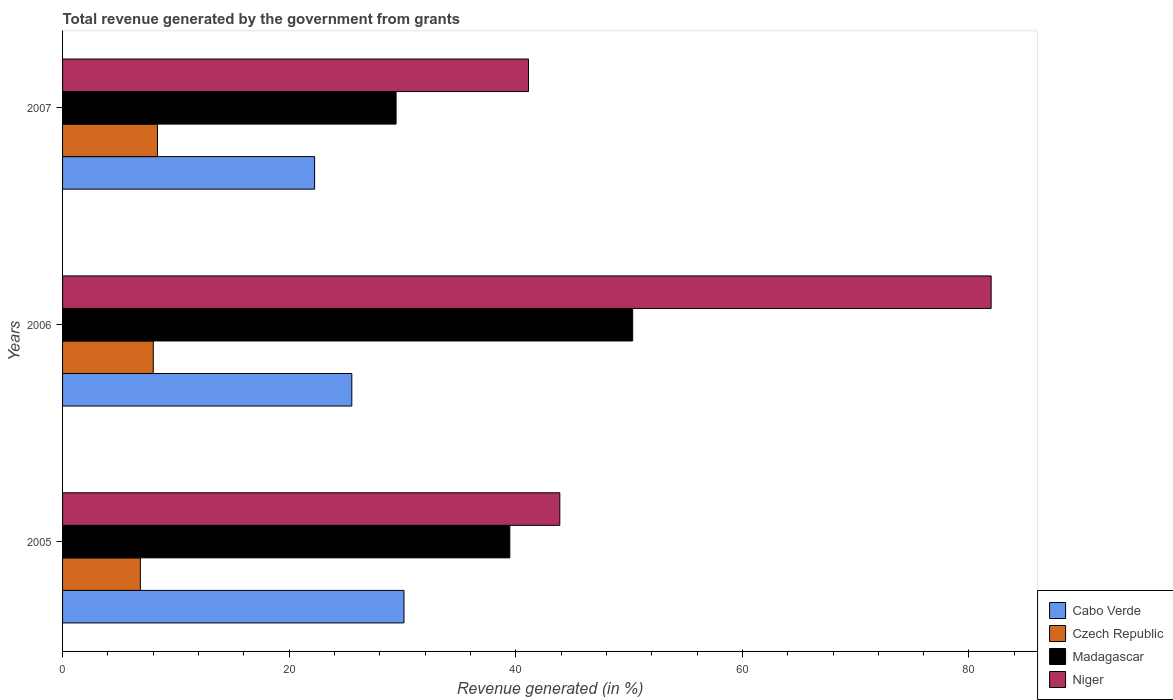How many different coloured bars are there?
Provide a succinct answer. 4. Are the number of bars on each tick of the Y-axis equal?
Keep it short and to the point. Yes. How many bars are there on the 3rd tick from the top?
Ensure brevity in your answer.  4. What is the total revenue generated in Madagascar in 2005?
Provide a succinct answer. 39.48. Across all years, what is the maximum total revenue generated in Cabo Verde?
Provide a succinct answer. 30.13. Across all years, what is the minimum total revenue generated in Niger?
Ensure brevity in your answer.  41.12. What is the total total revenue generated in Cabo Verde in the graph?
Offer a very short reply. 77.91. What is the difference between the total revenue generated in Madagascar in 2005 and that in 2006?
Your answer should be compact. -10.84. What is the difference between the total revenue generated in Niger in 2006 and the total revenue generated in Czech Republic in 2007?
Keep it short and to the point. 73.58. What is the average total revenue generated in Niger per year?
Your answer should be compact. 55.65. In the year 2005, what is the difference between the total revenue generated in Czech Republic and total revenue generated in Cabo Verde?
Offer a terse response. -23.27. In how many years, is the total revenue generated in Niger greater than 16 %?
Provide a short and direct response. 3. What is the ratio of the total revenue generated in Cabo Verde in 2005 to that in 2006?
Your answer should be compact. 1.18. Is the total revenue generated in Niger in 2005 less than that in 2007?
Your answer should be very brief. No. Is the difference between the total revenue generated in Czech Republic in 2006 and 2007 greater than the difference between the total revenue generated in Cabo Verde in 2006 and 2007?
Provide a succinct answer. No. What is the difference between the highest and the second highest total revenue generated in Czech Republic?
Offer a terse response. 0.37. What is the difference between the highest and the lowest total revenue generated in Madagascar?
Give a very brief answer. 20.88. In how many years, is the total revenue generated in Czech Republic greater than the average total revenue generated in Czech Republic taken over all years?
Ensure brevity in your answer.  2. Is the sum of the total revenue generated in Madagascar in 2006 and 2007 greater than the maximum total revenue generated in Cabo Verde across all years?
Provide a succinct answer. Yes. Is it the case that in every year, the sum of the total revenue generated in Cabo Verde and total revenue generated in Czech Republic is greater than the sum of total revenue generated in Madagascar and total revenue generated in Niger?
Make the answer very short. No. What does the 4th bar from the top in 2005 represents?
Provide a short and direct response. Cabo Verde. What does the 3rd bar from the bottom in 2005 represents?
Provide a short and direct response. Madagascar. Is it the case that in every year, the sum of the total revenue generated in Cabo Verde and total revenue generated in Madagascar is greater than the total revenue generated in Niger?
Keep it short and to the point. No. How many bars are there?
Offer a terse response. 12. Are all the bars in the graph horizontal?
Your answer should be very brief. Yes. How many years are there in the graph?
Provide a short and direct response. 3. What is the difference between two consecutive major ticks on the X-axis?
Offer a terse response. 20. Are the values on the major ticks of X-axis written in scientific E-notation?
Your response must be concise. No. Does the graph contain any zero values?
Keep it short and to the point. No. How many legend labels are there?
Offer a very short reply. 4. What is the title of the graph?
Make the answer very short. Total revenue generated by the government from grants. Does "Eritrea" appear as one of the legend labels in the graph?
Provide a short and direct response. No. What is the label or title of the X-axis?
Offer a terse response. Revenue generated (in %). What is the Revenue generated (in %) in Cabo Verde in 2005?
Provide a short and direct response. 30.13. What is the Revenue generated (in %) in Czech Republic in 2005?
Provide a short and direct response. 6.87. What is the Revenue generated (in %) of Madagascar in 2005?
Provide a succinct answer. 39.48. What is the Revenue generated (in %) in Niger in 2005?
Offer a terse response. 43.89. What is the Revenue generated (in %) of Cabo Verde in 2006?
Give a very brief answer. 25.53. What is the Revenue generated (in %) of Czech Republic in 2006?
Your answer should be compact. 8.01. What is the Revenue generated (in %) in Madagascar in 2006?
Offer a very short reply. 50.32. What is the Revenue generated (in %) in Niger in 2006?
Offer a terse response. 81.96. What is the Revenue generated (in %) in Cabo Verde in 2007?
Your answer should be very brief. 22.25. What is the Revenue generated (in %) in Czech Republic in 2007?
Make the answer very short. 8.37. What is the Revenue generated (in %) of Madagascar in 2007?
Make the answer very short. 29.44. What is the Revenue generated (in %) of Niger in 2007?
Offer a very short reply. 41.12. Across all years, what is the maximum Revenue generated (in %) of Cabo Verde?
Keep it short and to the point. 30.13. Across all years, what is the maximum Revenue generated (in %) of Czech Republic?
Provide a short and direct response. 8.37. Across all years, what is the maximum Revenue generated (in %) of Madagascar?
Your answer should be very brief. 50.32. Across all years, what is the maximum Revenue generated (in %) of Niger?
Make the answer very short. 81.96. Across all years, what is the minimum Revenue generated (in %) of Cabo Verde?
Provide a short and direct response. 22.25. Across all years, what is the minimum Revenue generated (in %) of Czech Republic?
Give a very brief answer. 6.87. Across all years, what is the minimum Revenue generated (in %) of Madagascar?
Provide a short and direct response. 29.44. Across all years, what is the minimum Revenue generated (in %) of Niger?
Offer a very short reply. 41.12. What is the total Revenue generated (in %) of Cabo Verde in the graph?
Provide a succinct answer. 77.91. What is the total Revenue generated (in %) of Czech Republic in the graph?
Offer a very short reply. 23.25. What is the total Revenue generated (in %) in Madagascar in the graph?
Your answer should be compact. 119.23. What is the total Revenue generated (in %) of Niger in the graph?
Give a very brief answer. 166.96. What is the difference between the Revenue generated (in %) of Cabo Verde in 2005 and that in 2006?
Make the answer very short. 4.61. What is the difference between the Revenue generated (in %) in Czech Republic in 2005 and that in 2006?
Give a very brief answer. -1.14. What is the difference between the Revenue generated (in %) in Madagascar in 2005 and that in 2006?
Make the answer very short. -10.84. What is the difference between the Revenue generated (in %) in Niger in 2005 and that in 2006?
Make the answer very short. -38.07. What is the difference between the Revenue generated (in %) in Cabo Verde in 2005 and that in 2007?
Your response must be concise. 7.89. What is the difference between the Revenue generated (in %) of Czech Republic in 2005 and that in 2007?
Provide a succinct answer. -1.51. What is the difference between the Revenue generated (in %) of Madagascar in 2005 and that in 2007?
Offer a very short reply. 10.04. What is the difference between the Revenue generated (in %) in Niger in 2005 and that in 2007?
Ensure brevity in your answer.  2.76. What is the difference between the Revenue generated (in %) in Cabo Verde in 2006 and that in 2007?
Your response must be concise. 3.28. What is the difference between the Revenue generated (in %) in Czech Republic in 2006 and that in 2007?
Your response must be concise. -0.37. What is the difference between the Revenue generated (in %) in Madagascar in 2006 and that in 2007?
Provide a succinct answer. 20.88. What is the difference between the Revenue generated (in %) of Niger in 2006 and that in 2007?
Offer a very short reply. 40.83. What is the difference between the Revenue generated (in %) of Cabo Verde in 2005 and the Revenue generated (in %) of Czech Republic in 2006?
Provide a succinct answer. 22.13. What is the difference between the Revenue generated (in %) of Cabo Verde in 2005 and the Revenue generated (in %) of Madagascar in 2006?
Ensure brevity in your answer.  -20.18. What is the difference between the Revenue generated (in %) of Cabo Verde in 2005 and the Revenue generated (in %) of Niger in 2006?
Give a very brief answer. -51.82. What is the difference between the Revenue generated (in %) in Czech Republic in 2005 and the Revenue generated (in %) in Madagascar in 2006?
Keep it short and to the point. -43.45. What is the difference between the Revenue generated (in %) in Czech Republic in 2005 and the Revenue generated (in %) in Niger in 2006?
Give a very brief answer. -75.09. What is the difference between the Revenue generated (in %) in Madagascar in 2005 and the Revenue generated (in %) in Niger in 2006?
Make the answer very short. -42.48. What is the difference between the Revenue generated (in %) in Cabo Verde in 2005 and the Revenue generated (in %) in Czech Republic in 2007?
Your response must be concise. 21.76. What is the difference between the Revenue generated (in %) of Cabo Verde in 2005 and the Revenue generated (in %) of Madagascar in 2007?
Offer a very short reply. 0.7. What is the difference between the Revenue generated (in %) in Cabo Verde in 2005 and the Revenue generated (in %) in Niger in 2007?
Your answer should be compact. -10.99. What is the difference between the Revenue generated (in %) of Czech Republic in 2005 and the Revenue generated (in %) of Madagascar in 2007?
Your response must be concise. -22.57. What is the difference between the Revenue generated (in %) in Czech Republic in 2005 and the Revenue generated (in %) in Niger in 2007?
Your answer should be compact. -34.26. What is the difference between the Revenue generated (in %) in Madagascar in 2005 and the Revenue generated (in %) in Niger in 2007?
Your answer should be compact. -1.65. What is the difference between the Revenue generated (in %) in Cabo Verde in 2006 and the Revenue generated (in %) in Czech Republic in 2007?
Offer a terse response. 17.15. What is the difference between the Revenue generated (in %) of Cabo Verde in 2006 and the Revenue generated (in %) of Madagascar in 2007?
Give a very brief answer. -3.91. What is the difference between the Revenue generated (in %) in Cabo Verde in 2006 and the Revenue generated (in %) in Niger in 2007?
Your answer should be very brief. -15.6. What is the difference between the Revenue generated (in %) of Czech Republic in 2006 and the Revenue generated (in %) of Madagascar in 2007?
Your response must be concise. -21.43. What is the difference between the Revenue generated (in %) in Czech Republic in 2006 and the Revenue generated (in %) in Niger in 2007?
Offer a very short reply. -33.12. What is the difference between the Revenue generated (in %) of Madagascar in 2006 and the Revenue generated (in %) of Niger in 2007?
Your answer should be compact. 9.19. What is the average Revenue generated (in %) of Cabo Verde per year?
Offer a terse response. 25.97. What is the average Revenue generated (in %) in Czech Republic per year?
Offer a very short reply. 7.75. What is the average Revenue generated (in %) of Madagascar per year?
Offer a terse response. 39.74. What is the average Revenue generated (in %) in Niger per year?
Your answer should be very brief. 55.65. In the year 2005, what is the difference between the Revenue generated (in %) of Cabo Verde and Revenue generated (in %) of Czech Republic?
Ensure brevity in your answer.  23.27. In the year 2005, what is the difference between the Revenue generated (in %) of Cabo Verde and Revenue generated (in %) of Madagascar?
Provide a succinct answer. -9.34. In the year 2005, what is the difference between the Revenue generated (in %) in Cabo Verde and Revenue generated (in %) in Niger?
Your answer should be compact. -13.75. In the year 2005, what is the difference between the Revenue generated (in %) of Czech Republic and Revenue generated (in %) of Madagascar?
Your response must be concise. -32.61. In the year 2005, what is the difference between the Revenue generated (in %) in Czech Republic and Revenue generated (in %) in Niger?
Your answer should be very brief. -37.02. In the year 2005, what is the difference between the Revenue generated (in %) of Madagascar and Revenue generated (in %) of Niger?
Your answer should be very brief. -4.41. In the year 2006, what is the difference between the Revenue generated (in %) in Cabo Verde and Revenue generated (in %) in Czech Republic?
Offer a terse response. 17.52. In the year 2006, what is the difference between the Revenue generated (in %) of Cabo Verde and Revenue generated (in %) of Madagascar?
Offer a terse response. -24.79. In the year 2006, what is the difference between the Revenue generated (in %) in Cabo Verde and Revenue generated (in %) in Niger?
Your response must be concise. -56.43. In the year 2006, what is the difference between the Revenue generated (in %) in Czech Republic and Revenue generated (in %) in Madagascar?
Keep it short and to the point. -42.31. In the year 2006, what is the difference between the Revenue generated (in %) of Czech Republic and Revenue generated (in %) of Niger?
Your answer should be compact. -73.95. In the year 2006, what is the difference between the Revenue generated (in %) in Madagascar and Revenue generated (in %) in Niger?
Your answer should be compact. -31.64. In the year 2007, what is the difference between the Revenue generated (in %) of Cabo Verde and Revenue generated (in %) of Czech Republic?
Ensure brevity in your answer.  13.87. In the year 2007, what is the difference between the Revenue generated (in %) in Cabo Verde and Revenue generated (in %) in Madagascar?
Keep it short and to the point. -7.19. In the year 2007, what is the difference between the Revenue generated (in %) of Cabo Verde and Revenue generated (in %) of Niger?
Ensure brevity in your answer.  -18.88. In the year 2007, what is the difference between the Revenue generated (in %) in Czech Republic and Revenue generated (in %) in Madagascar?
Provide a succinct answer. -21.06. In the year 2007, what is the difference between the Revenue generated (in %) of Czech Republic and Revenue generated (in %) of Niger?
Provide a short and direct response. -32.75. In the year 2007, what is the difference between the Revenue generated (in %) of Madagascar and Revenue generated (in %) of Niger?
Your answer should be very brief. -11.69. What is the ratio of the Revenue generated (in %) of Cabo Verde in 2005 to that in 2006?
Provide a succinct answer. 1.18. What is the ratio of the Revenue generated (in %) in Czech Republic in 2005 to that in 2006?
Make the answer very short. 0.86. What is the ratio of the Revenue generated (in %) of Madagascar in 2005 to that in 2006?
Offer a very short reply. 0.78. What is the ratio of the Revenue generated (in %) of Niger in 2005 to that in 2006?
Provide a succinct answer. 0.54. What is the ratio of the Revenue generated (in %) of Cabo Verde in 2005 to that in 2007?
Make the answer very short. 1.35. What is the ratio of the Revenue generated (in %) in Czech Republic in 2005 to that in 2007?
Offer a terse response. 0.82. What is the ratio of the Revenue generated (in %) of Madagascar in 2005 to that in 2007?
Give a very brief answer. 1.34. What is the ratio of the Revenue generated (in %) in Niger in 2005 to that in 2007?
Keep it short and to the point. 1.07. What is the ratio of the Revenue generated (in %) of Cabo Verde in 2006 to that in 2007?
Give a very brief answer. 1.15. What is the ratio of the Revenue generated (in %) of Czech Republic in 2006 to that in 2007?
Offer a very short reply. 0.96. What is the ratio of the Revenue generated (in %) of Madagascar in 2006 to that in 2007?
Make the answer very short. 1.71. What is the ratio of the Revenue generated (in %) of Niger in 2006 to that in 2007?
Make the answer very short. 1.99. What is the difference between the highest and the second highest Revenue generated (in %) of Cabo Verde?
Give a very brief answer. 4.61. What is the difference between the highest and the second highest Revenue generated (in %) in Czech Republic?
Offer a terse response. 0.37. What is the difference between the highest and the second highest Revenue generated (in %) in Madagascar?
Make the answer very short. 10.84. What is the difference between the highest and the second highest Revenue generated (in %) of Niger?
Offer a very short reply. 38.07. What is the difference between the highest and the lowest Revenue generated (in %) of Cabo Verde?
Keep it short and to the point. 7.89. What is the difference between the highest and the lowest Revenue generated (in %) of Czech Republic?
Ensure brevity in your answer.  1.51. What is the difference between the highest and the lowest Revenue generated (in %) in Madagascar?
Your answer should be compact. 20.88. What is the difference between the highest and the lowest Revenue generated (in %) of Niger?
Ensure brevity in your answer.  40.83. 